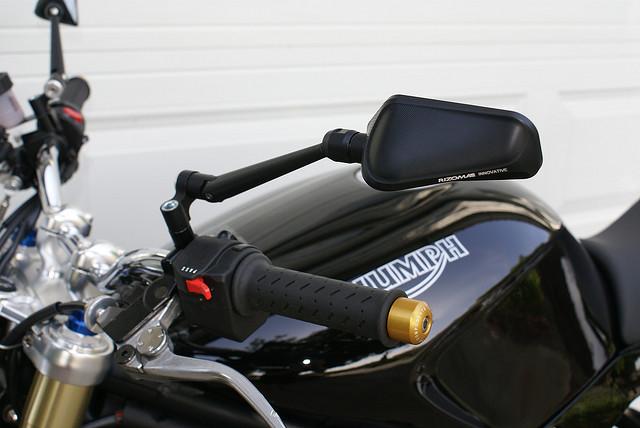What color is this bike?
Short answer required. Black. What type of vehicle is this?
Keep it brief. Motorcycle. Is this vehicle currently in use?
Quick response, please. No. 